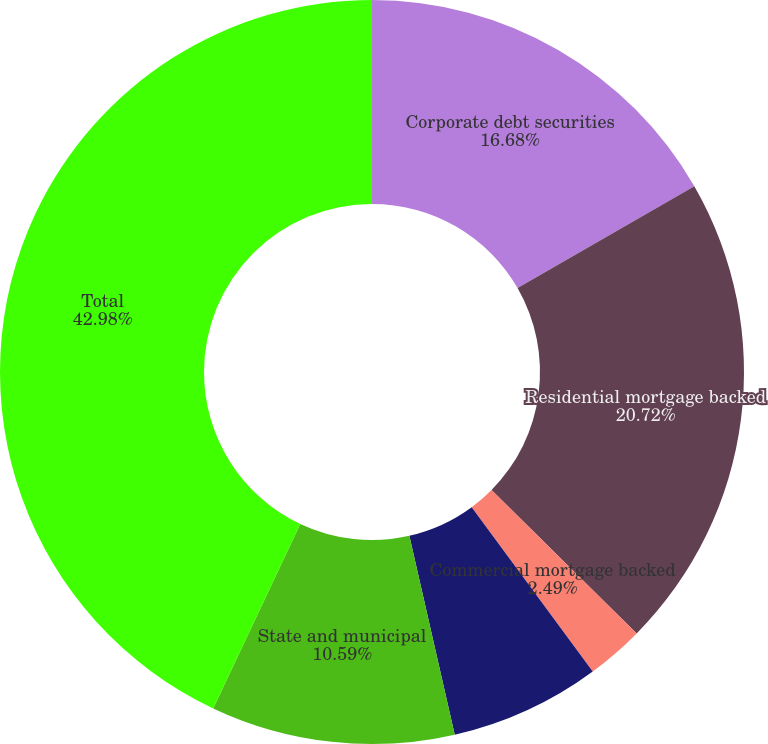Convert chart. <chart><loc_0><loc_0><loc_500><loc_500><pie_chart><fcel>Corporate debt securities<fcel>Residential mortgage backed<fcel>Commercial mortgage backed<fcel>Asset backed securities<fcel>State and municipal<fcel>Total<nl><fcel>16.68%<fcel>20.72%<fcel>2.49%<fcel>6.54%<fcel>10.59%<fcel>42.98%<nl></chart> 